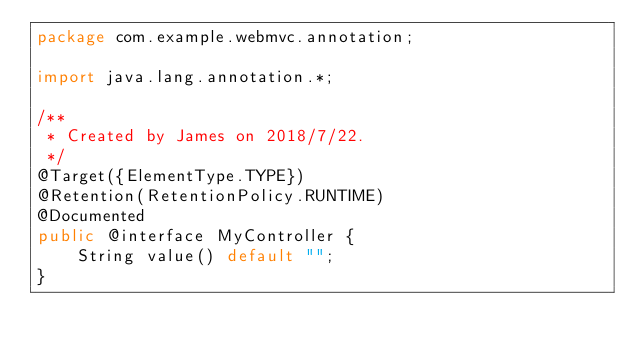<code> <loc_0><loc_0><loc_500><loc_500><_Java_>package com.example.webmvc.annotation;

import java.lang.annotation.*;

/**
 * Created by James on 2018/7/22.
 */
@Target({ElementType.TYPE})
@Retention(RetentionPolicy.RUNTIME)
@Documented
public @interface MyController {
    String value() default "";
}
</code> 